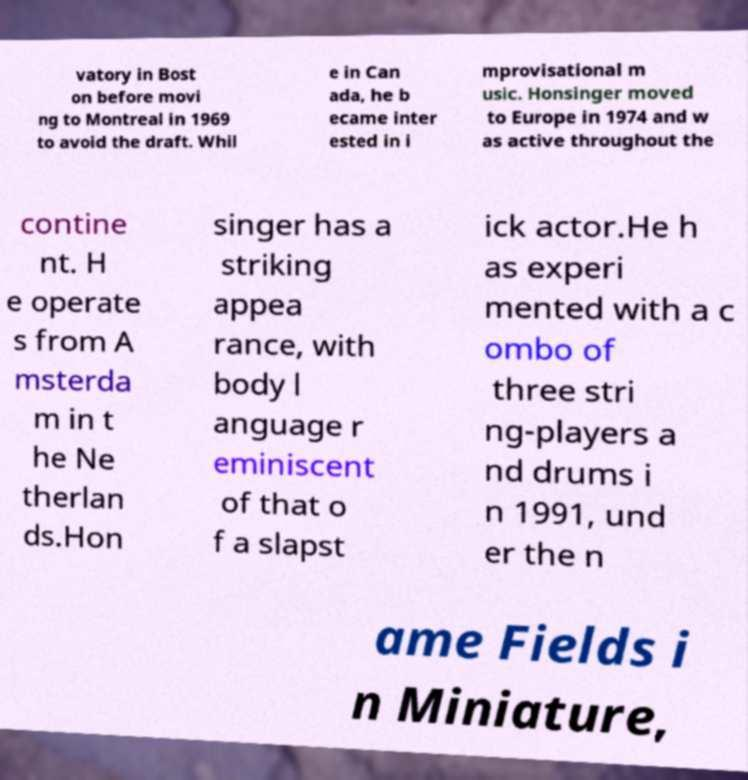There's text embedded in this image that I need extracted. Can you transcribe it verbatim? vatory in Bost on before movi ng to Montreal in 1969 to avoid the draft. Whil e in Can ada, he b ecame inter ested in i mprovisational m usic. Honsinger moved to Europe in 1974 and w as active throughout the contine nt. H e operate s from A msterda m in t he Ne therlan ds.Hon singer has a striking appea rance, with body l anguage r eminiscent of that o f a slapst ick actor.He h as experi mented with a c ombo of three stri ng-players a nd drums i n 1991, und er the n ame Fields i n Miniature, 